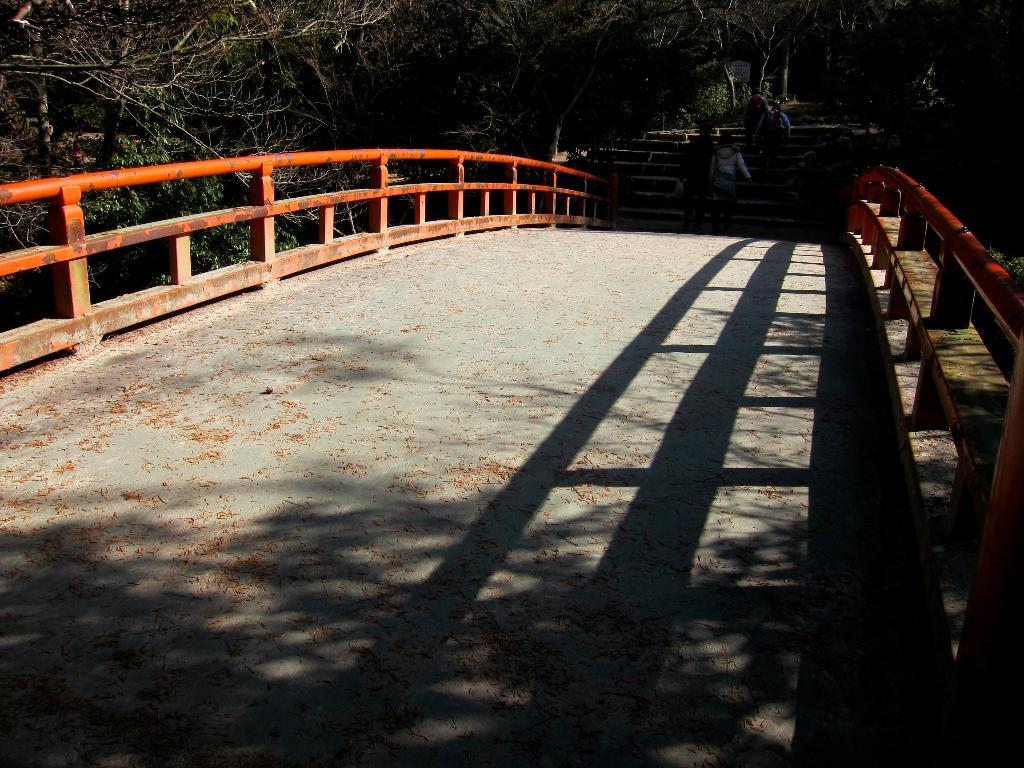What structure is present in the image? There is a bridge in the image. What feature does the bridge have? The bridge has a fence. What are the people in the image doing? There are people walking on the bridge and people climbing stairs. What can be seen in the background of the image? There are trees in the background of the image. Can you see any dinosaurs walking on the bridge in the image? No, there are no dinosaurs present in the image. What type of coat is the system wearing in the image? There is no system or coat present in the image. 